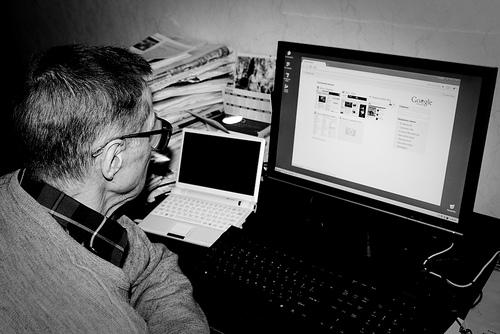What is the guy in glasses reading?
Answer briefly. Homepage. Is this man young?
Answer briefly. No. Is this man wearing glasses?
Be succinct. Yes. What color is the man's hair?
Concise answer only. Gray. How many comps are there?
Write a very short answer. 2. 